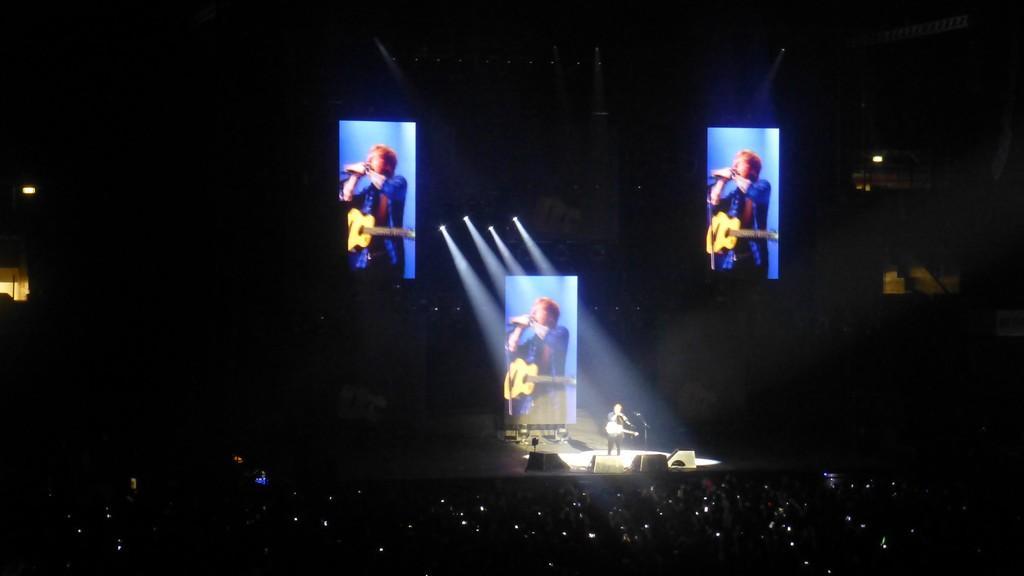In one or two sentences, can you explain what this image depicts? In this image there is a stage, there is a man standing on the stage, he is holding an object, he is wearing a musical instrument, there are objects on the stage, there are group of audience towards the bottom of the image, there are lights, there are screens, there is a man on the screen, there are light rays, the background of the image is dark. 